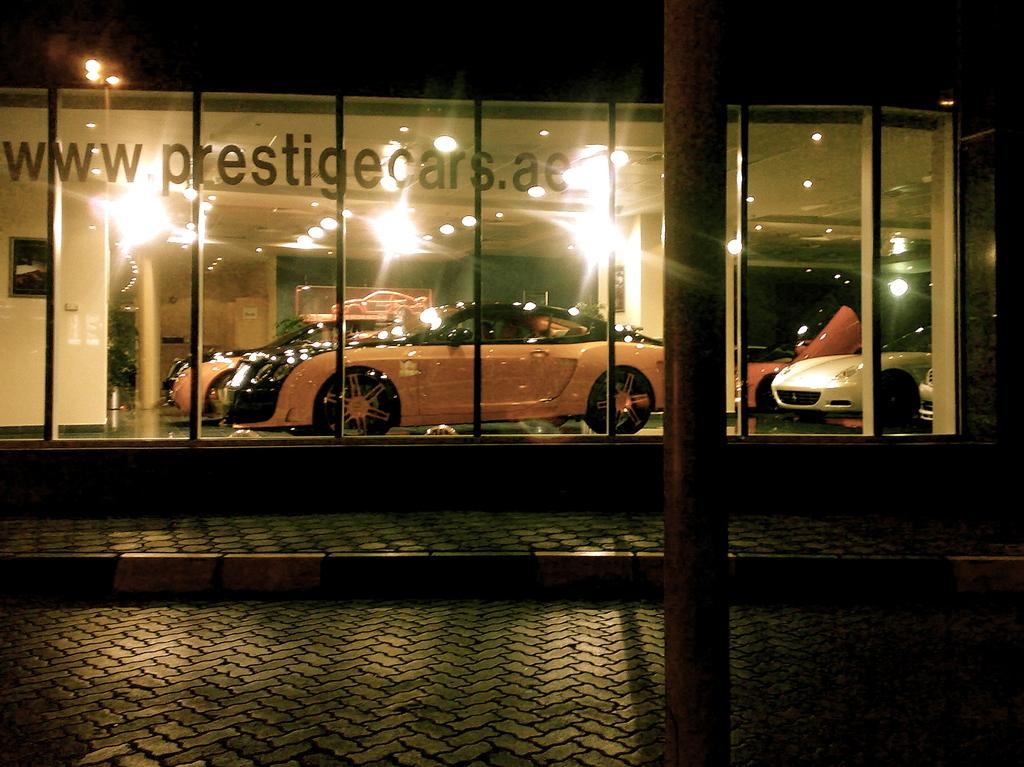What is the overall lighting condition in the image? The image is dark. What can be seen in the foreground of the image? There is pavement and a pole in the foreground of the image. What is visible in the background of the image? There are cars and lights inside the glass in the background of the image. Can you touch the stage in the image? There is no stage present in the image. What type of mine is visible in the background of the image? There is no mine present in the image. 